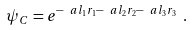<formula> <loc_0><loc_0><loc_500><loc_500>\psi _ { C } = e ^ { - \ a l _ { 1 } r _ { 1 } - \ a l _ { 2 } r _ { 2 } - \ a l _ { 3 } r _ { 3 } } \ .</formula> 